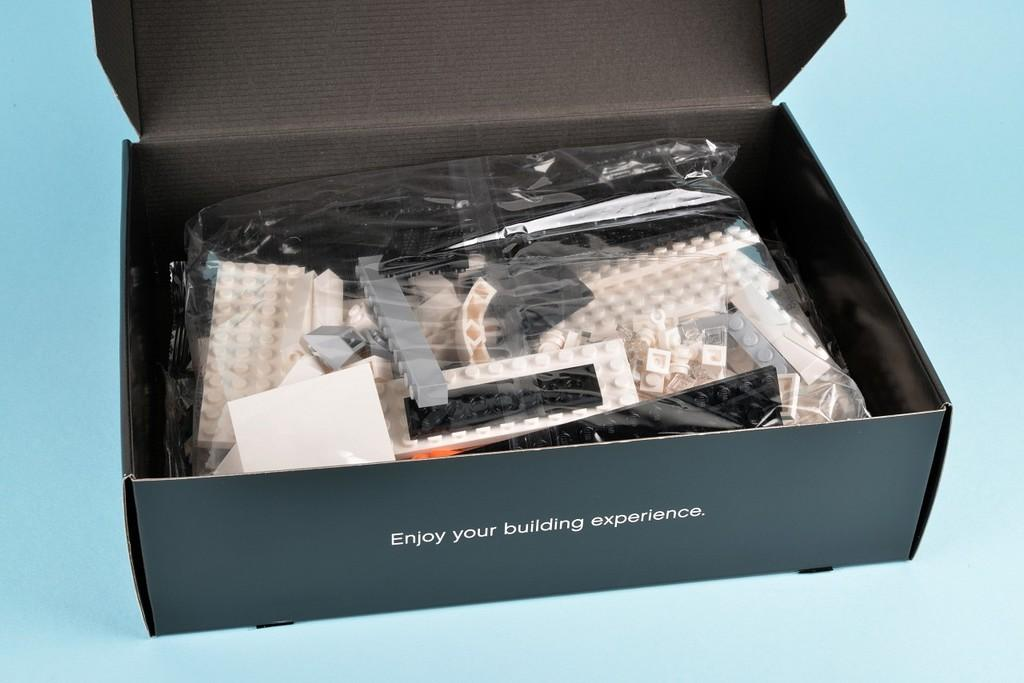<image>
Provide a brief description of the given image. A box of legos says Enjoy your building experience. 